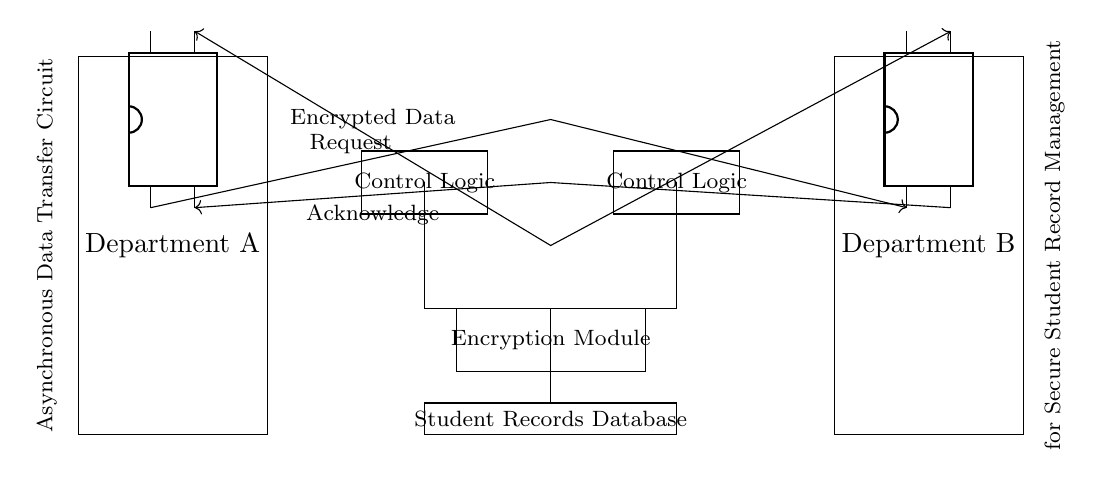What does the circuit manage? The circuit is designed for secure student record management, as indicated by the label in the circuit diagram.
Answer: Student record management What type of data is transferred? The diagram specifies that the type of data being transferred is encrypted data, as stated in the connection line labeled "Encrypted Data."
Answer: Encrypted data How many departments are involved? There are two departments shown in the circuit, labeled "Department A" and "Department B," which are the endpoints for the data transfer.
Answer: Two What role does the control logic play? Control logic in both departments is responsible for coordinating the asynchronous data transfers and ensuring that the data is sent or received properly, as represented by the rectangles labeled "Control Logic."
Answer: Coordination What triggers the data transfer? The "Request" line from Department A to Department B indicates that the initiation of the data transfer occurs through a request signal sent from Department A to Department B.
Answer: Request signal What is the purpose of the encryption module? The encryption module is included in the circuit to ensure that the data being transferred is secure, preventing unauthorized access during the transfer process.
Answer: Data security What is the direction of the acknowledge signal? The acknowledge signal flows from Department B back to Department A, as shown by the arrow direction on the "Acknowledge" line.
Answer: From Department B to Department A 